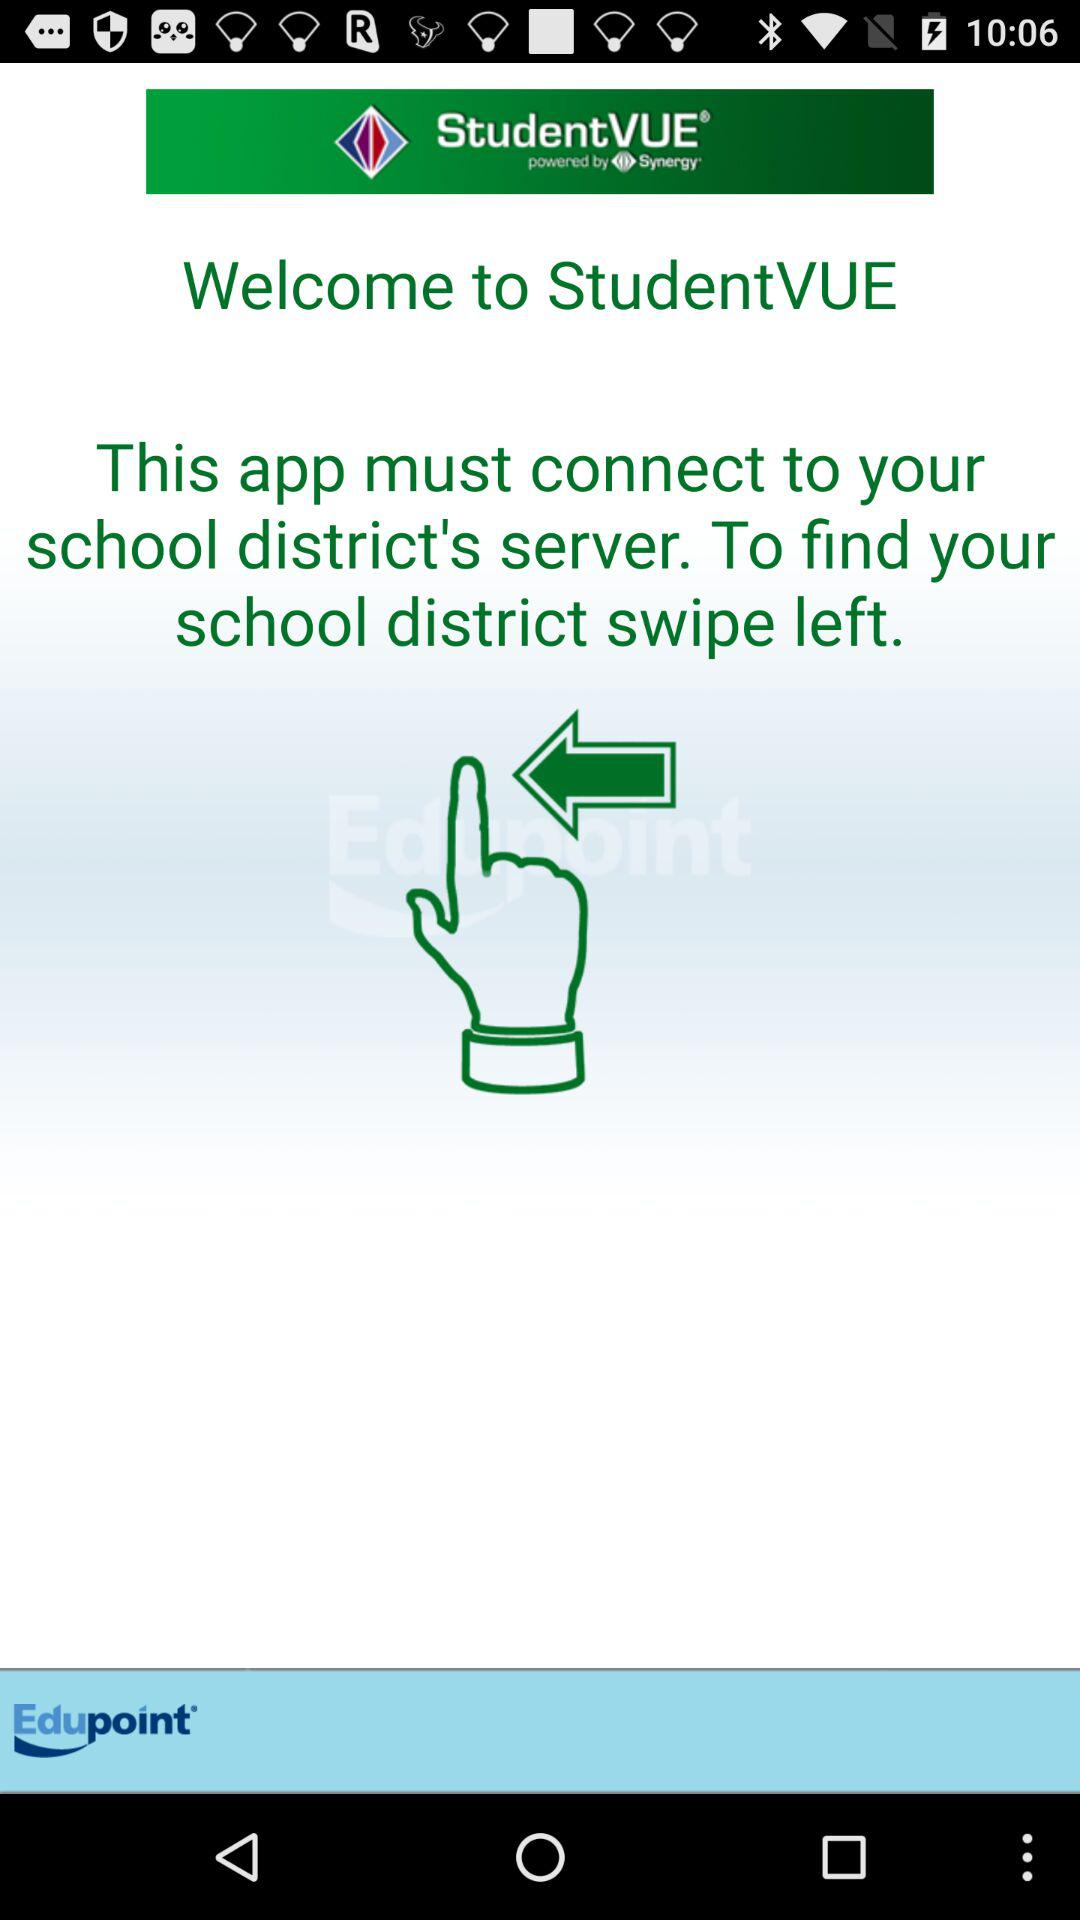What direction should I swipe to find my school district? To find your school district, you should swipe left. 